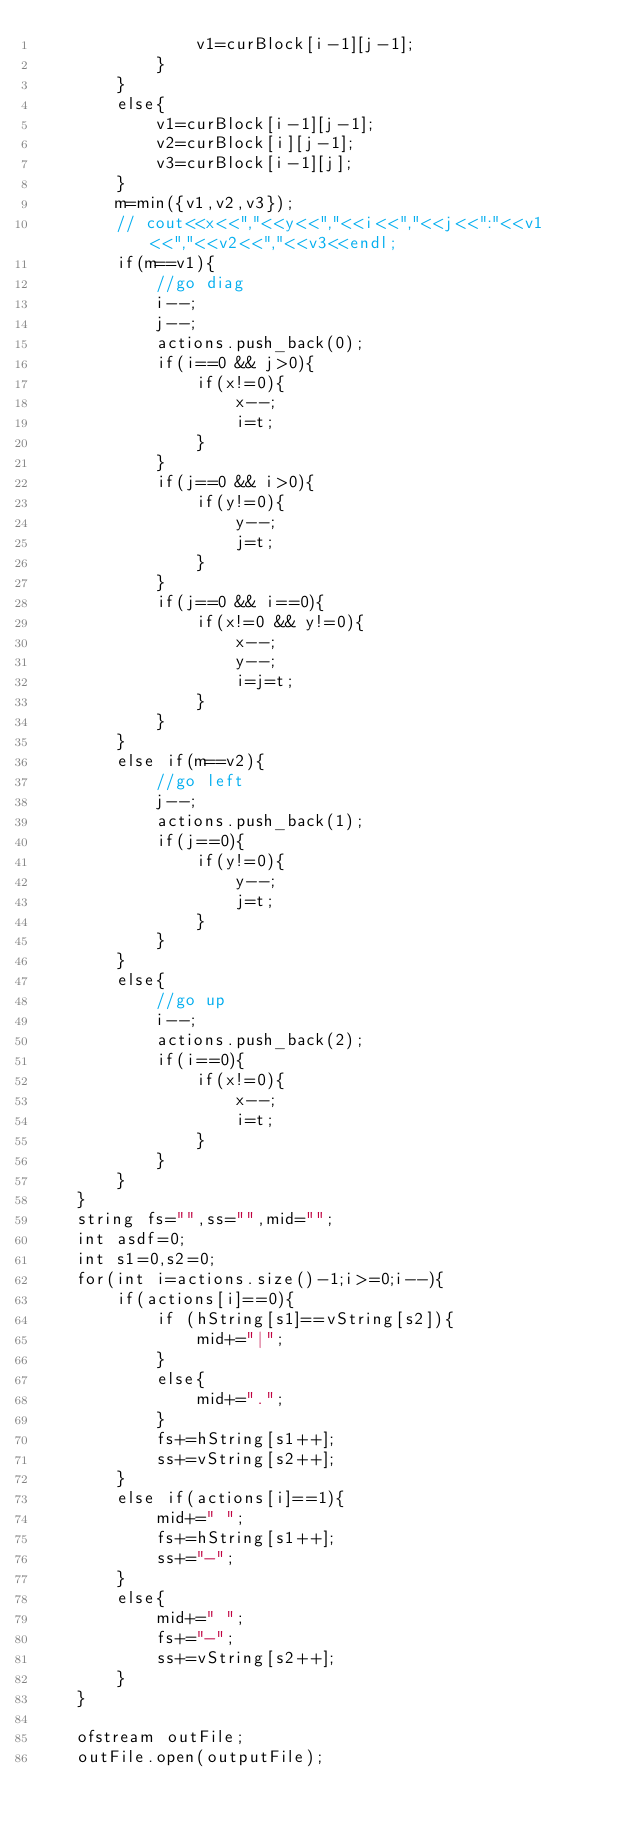<code> <loc_0><loc_0><loc_500><loc_500><_C++_>                v1=curBlock[i-1][j-1];
            }
        }
        else{
            v1=curBlock[i-1][j-1];
            v2=curBlock[i][j-1];
            v3=curBlock[i-1][j];
        }
        m=min({v1,v2,v3});
        // cout<<x<<","<<y<<","<<i<<","<<j<<":"<<v1<<","<<v2<<","<<v3<<endl;
        if(m==v1){
            //go diag
            i--;
            j--;
            actions.push_back(0);
            if(i==0 && j>0){
                if(x!=0){
                    x--;
                    i=t;
                }
            }
            if(j==0 && i>0){
                if(y!=0){
                    y--;
                    j=t;
                }
            }
            if(j==0 && i==0){
                if(x!=0 && y!=0){
                    x--;
                    y--;
                    i=j=t;
                }
            }
        }
        else if(m==v2){
            //go left
            j--;
            actions.push_back(1);
            if(j==0){
                if(y!=0){
                    y--;
                    j=t;
                }
            }
        }
        else{
            //go up
            i--;
            actions.push_back(2);
            if(i==0){
                if(x!=0){
                    x--;
                    i=t;
                }
            }
        }
    }
    string fs="",ss="",mid="";
    int asdf=0;
    int s1=0,s2=0;
    for(int i=actions.size()-1;i>=0;i--){
        if(actions[i]==0){
            if (hString[s1]==vString[s2]){
                mid+="|";
            }
            else{
                mid+=".";
            }
            fs+=hString[s1++];
            ss+=vString[s2++];
        }
        else if(actions[i]==1){
            mid+=" ";
            fs+=hString[s1++];
            ss+="-";
        }
        else{
            mid+=" ";
            fs+="-";
            ss+=vString[s2++];
        }
    }

    ofstream outFile;
    outFile.open(outputFile);</code> 